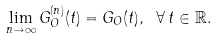<formula> <loc_0><loc_0><loc_500><loc_500>\lim _ { n \to \infty } G _ { O } ^ { ( n ) } ( t ) = G _ { O } ( t ) , \ \forall \, t \in \mathbb { R } .</formula> 